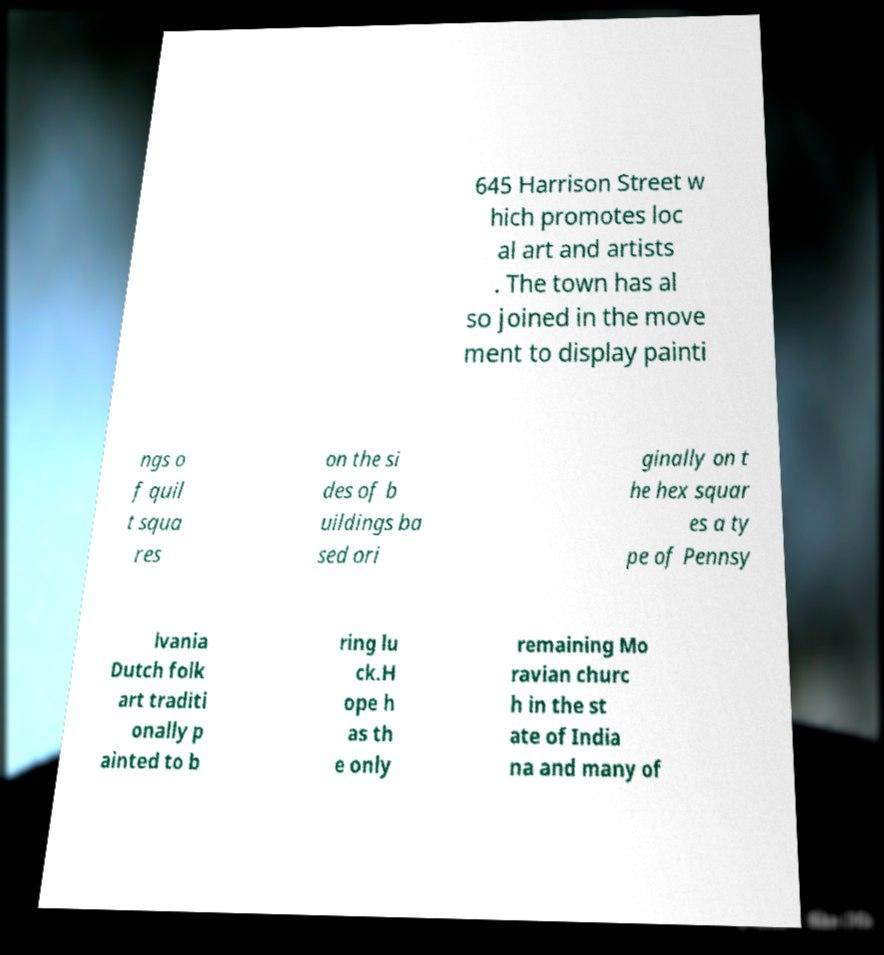I need the written content from this picture converted into text. Can you do that? 645 Harrison Street w hich promotes loc al art and artists . The town has al so joined in the move ment to display painti ngs o f quil t squa res on the si des of b uildings ba sed ori ginally on t he hex squar es a ty pe of Pennsy lvania Dutch folk art traditi onally p ainted to b ring lu ck.H ope h as th e only remaining Mo ravian churc h in the st ate of India na and many of 